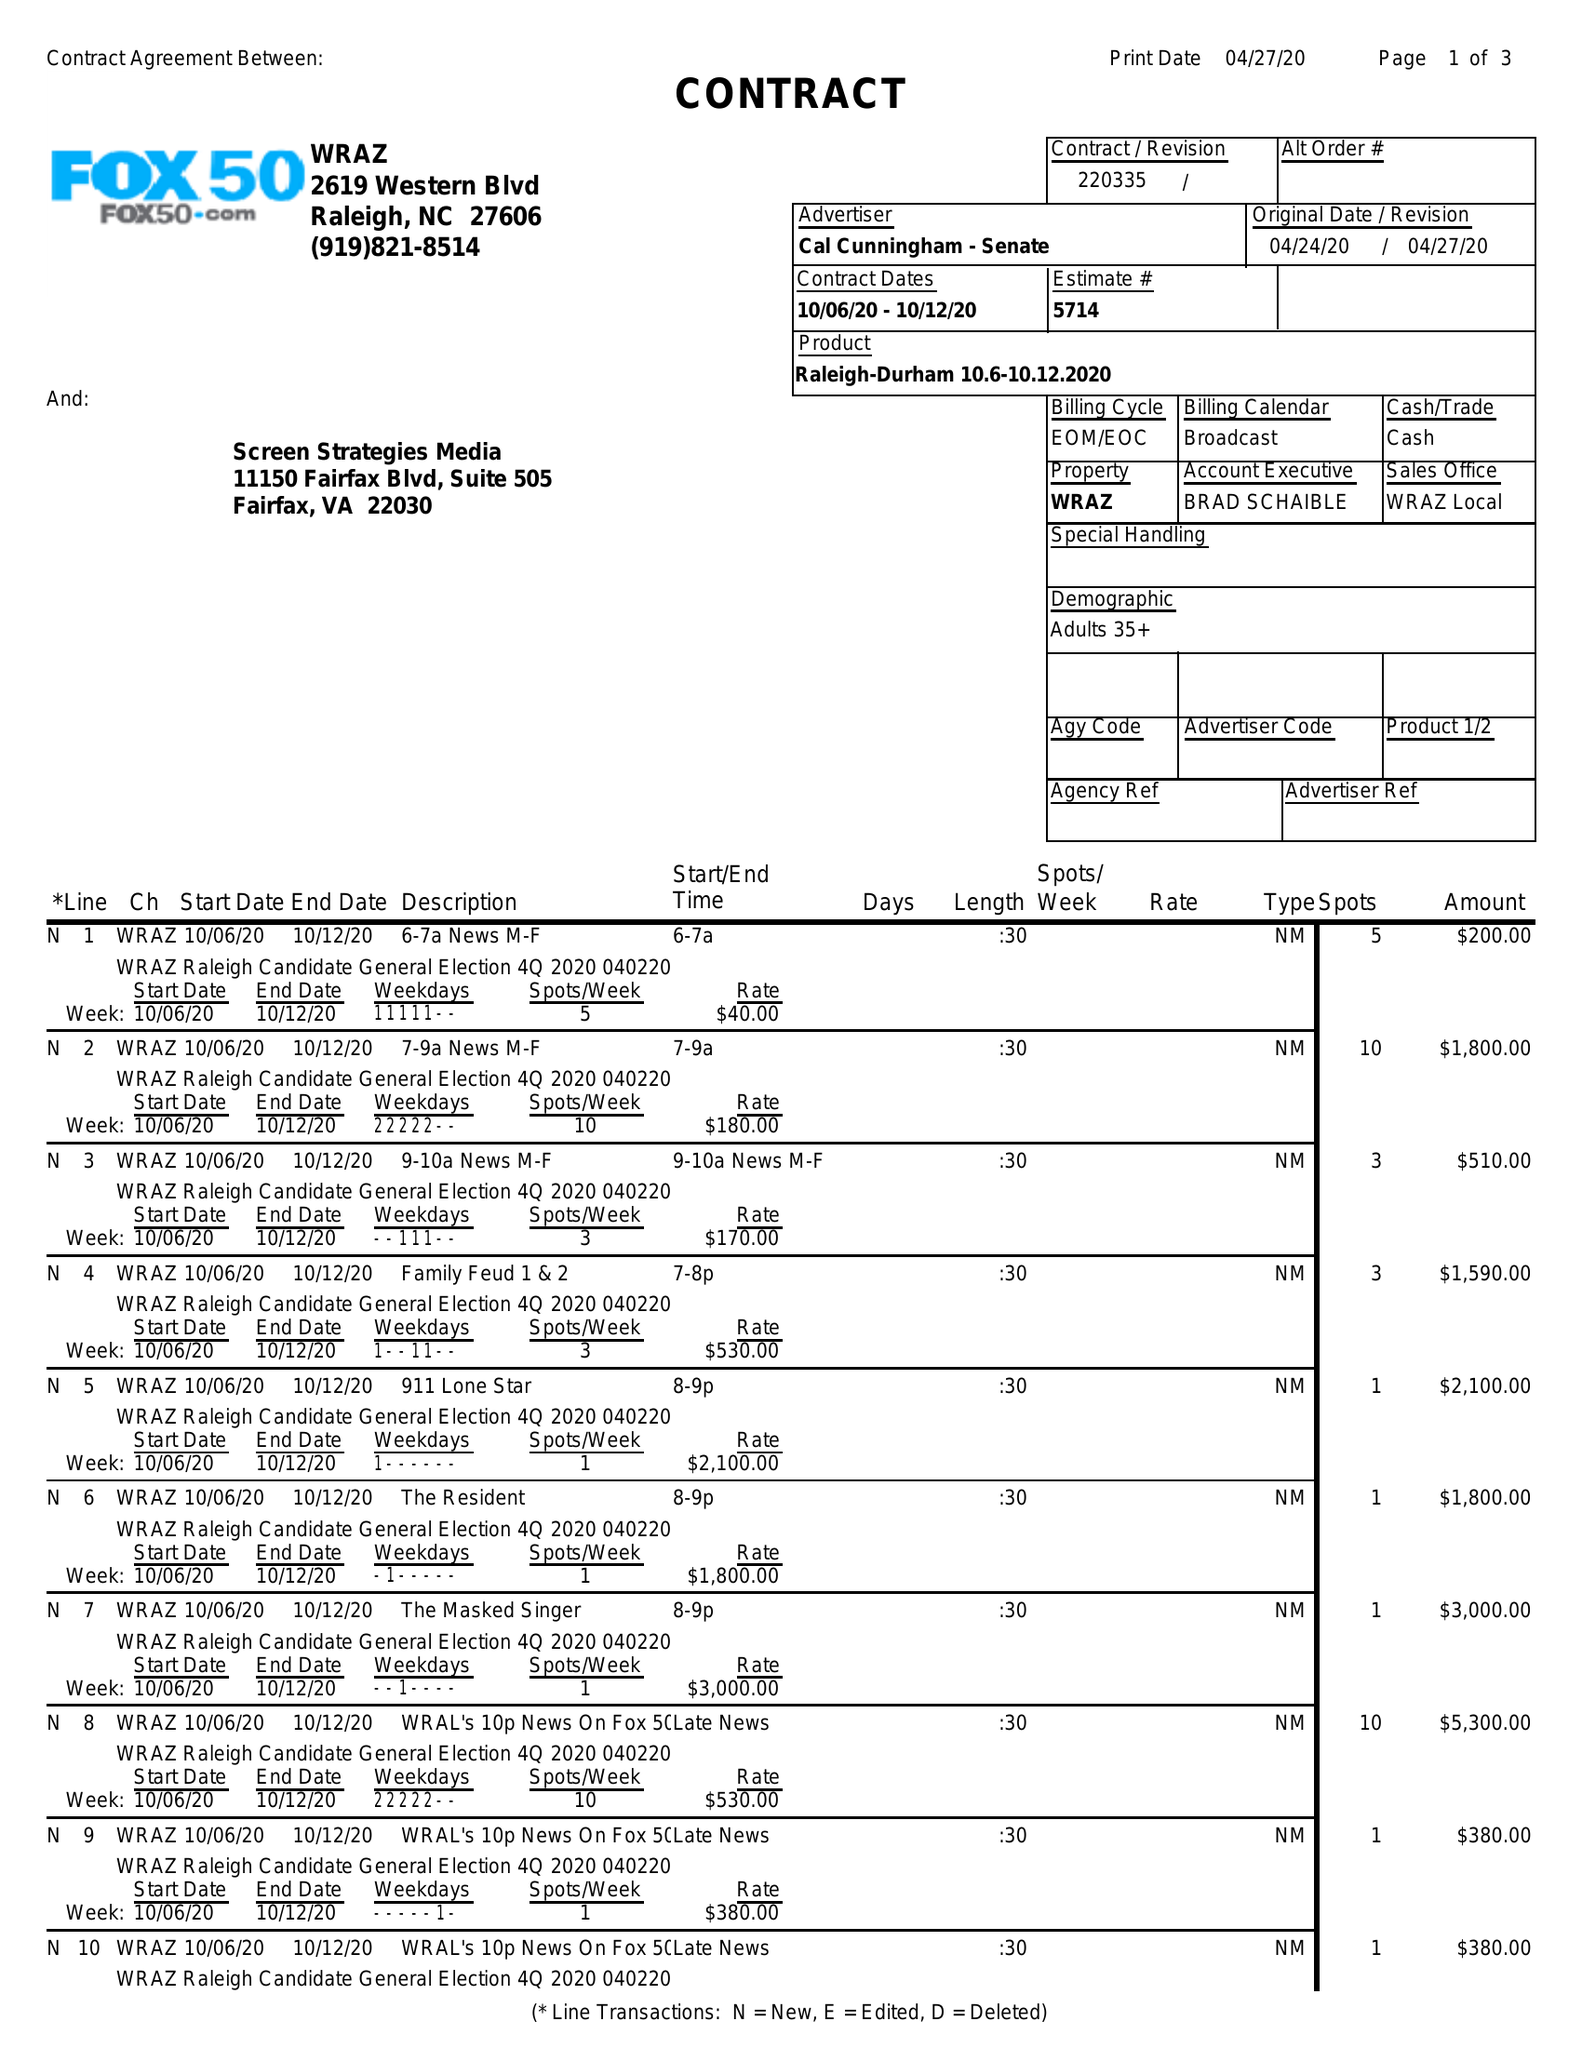What is the value for the gross_amount?
Answer the question using a single word or phrase. 17260.00 